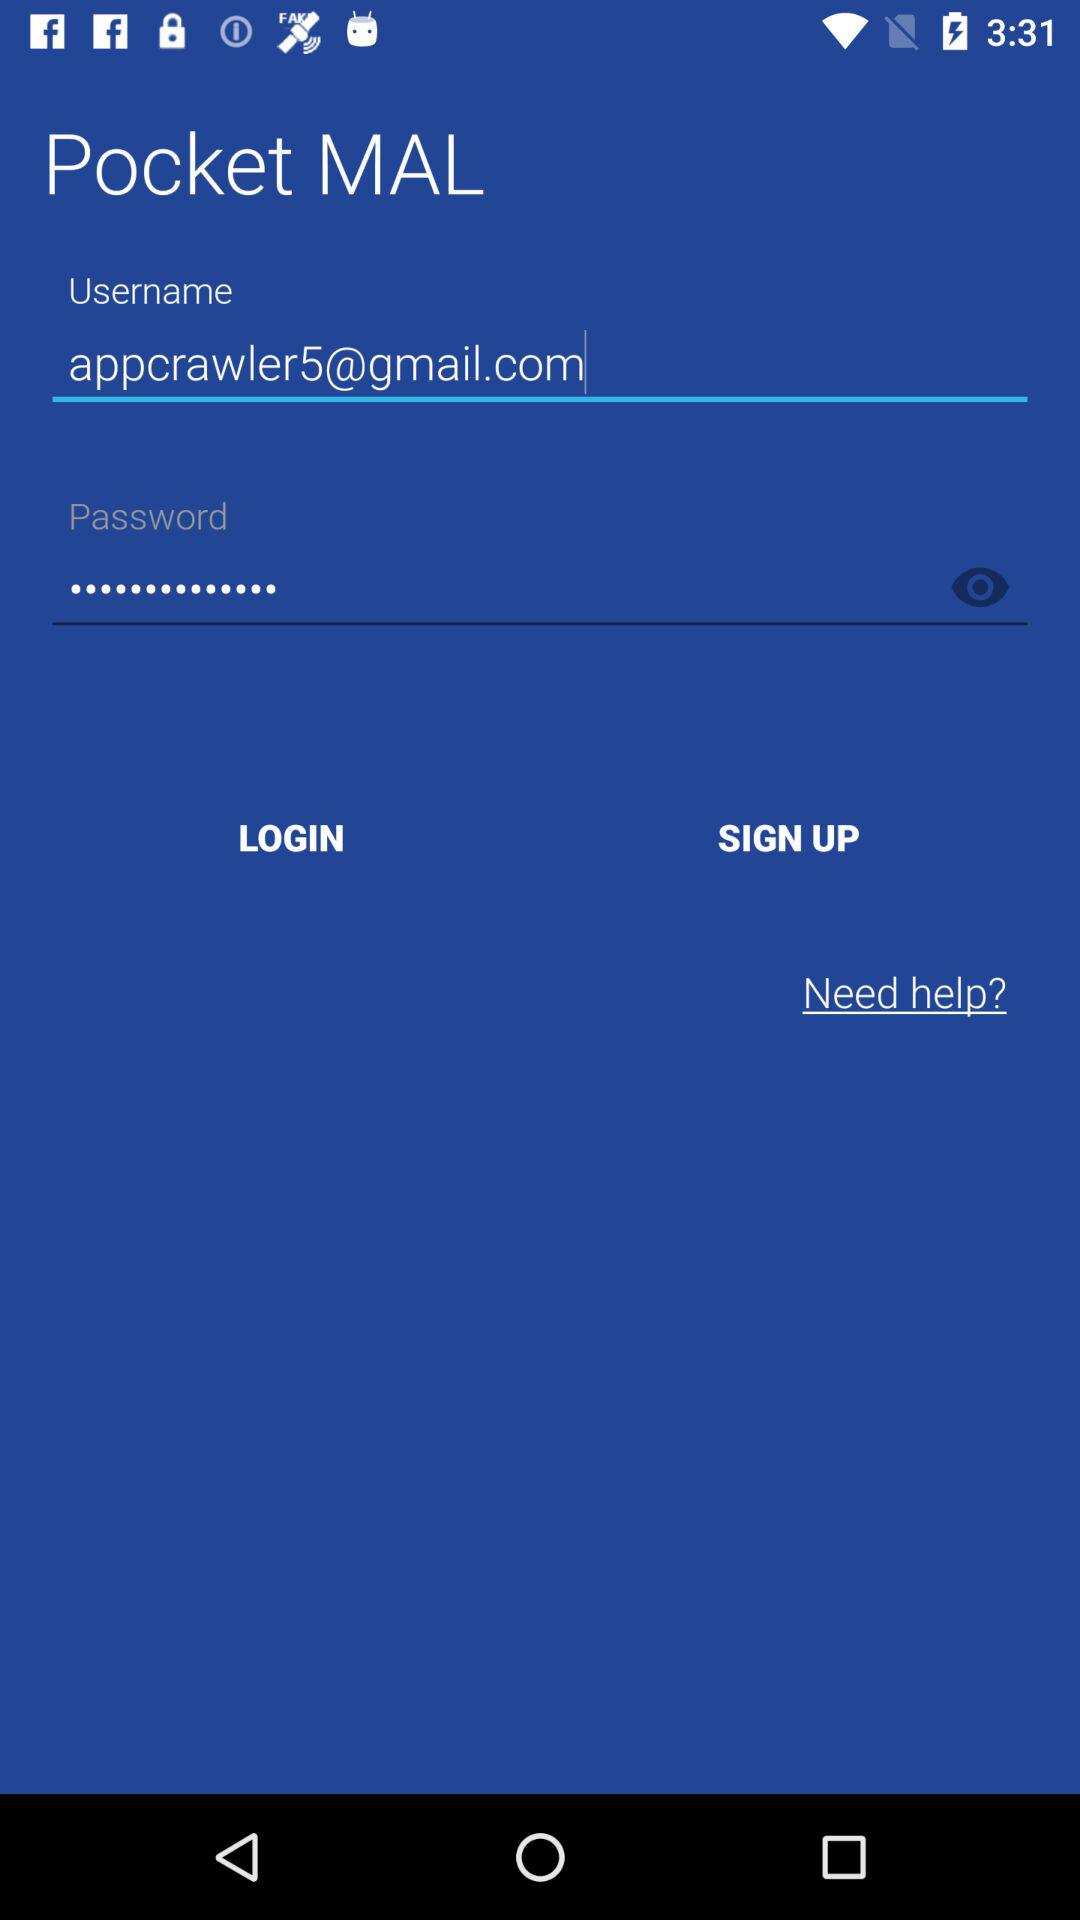What is the email address of the user? The email address is appcrawler5@gmail.com. 